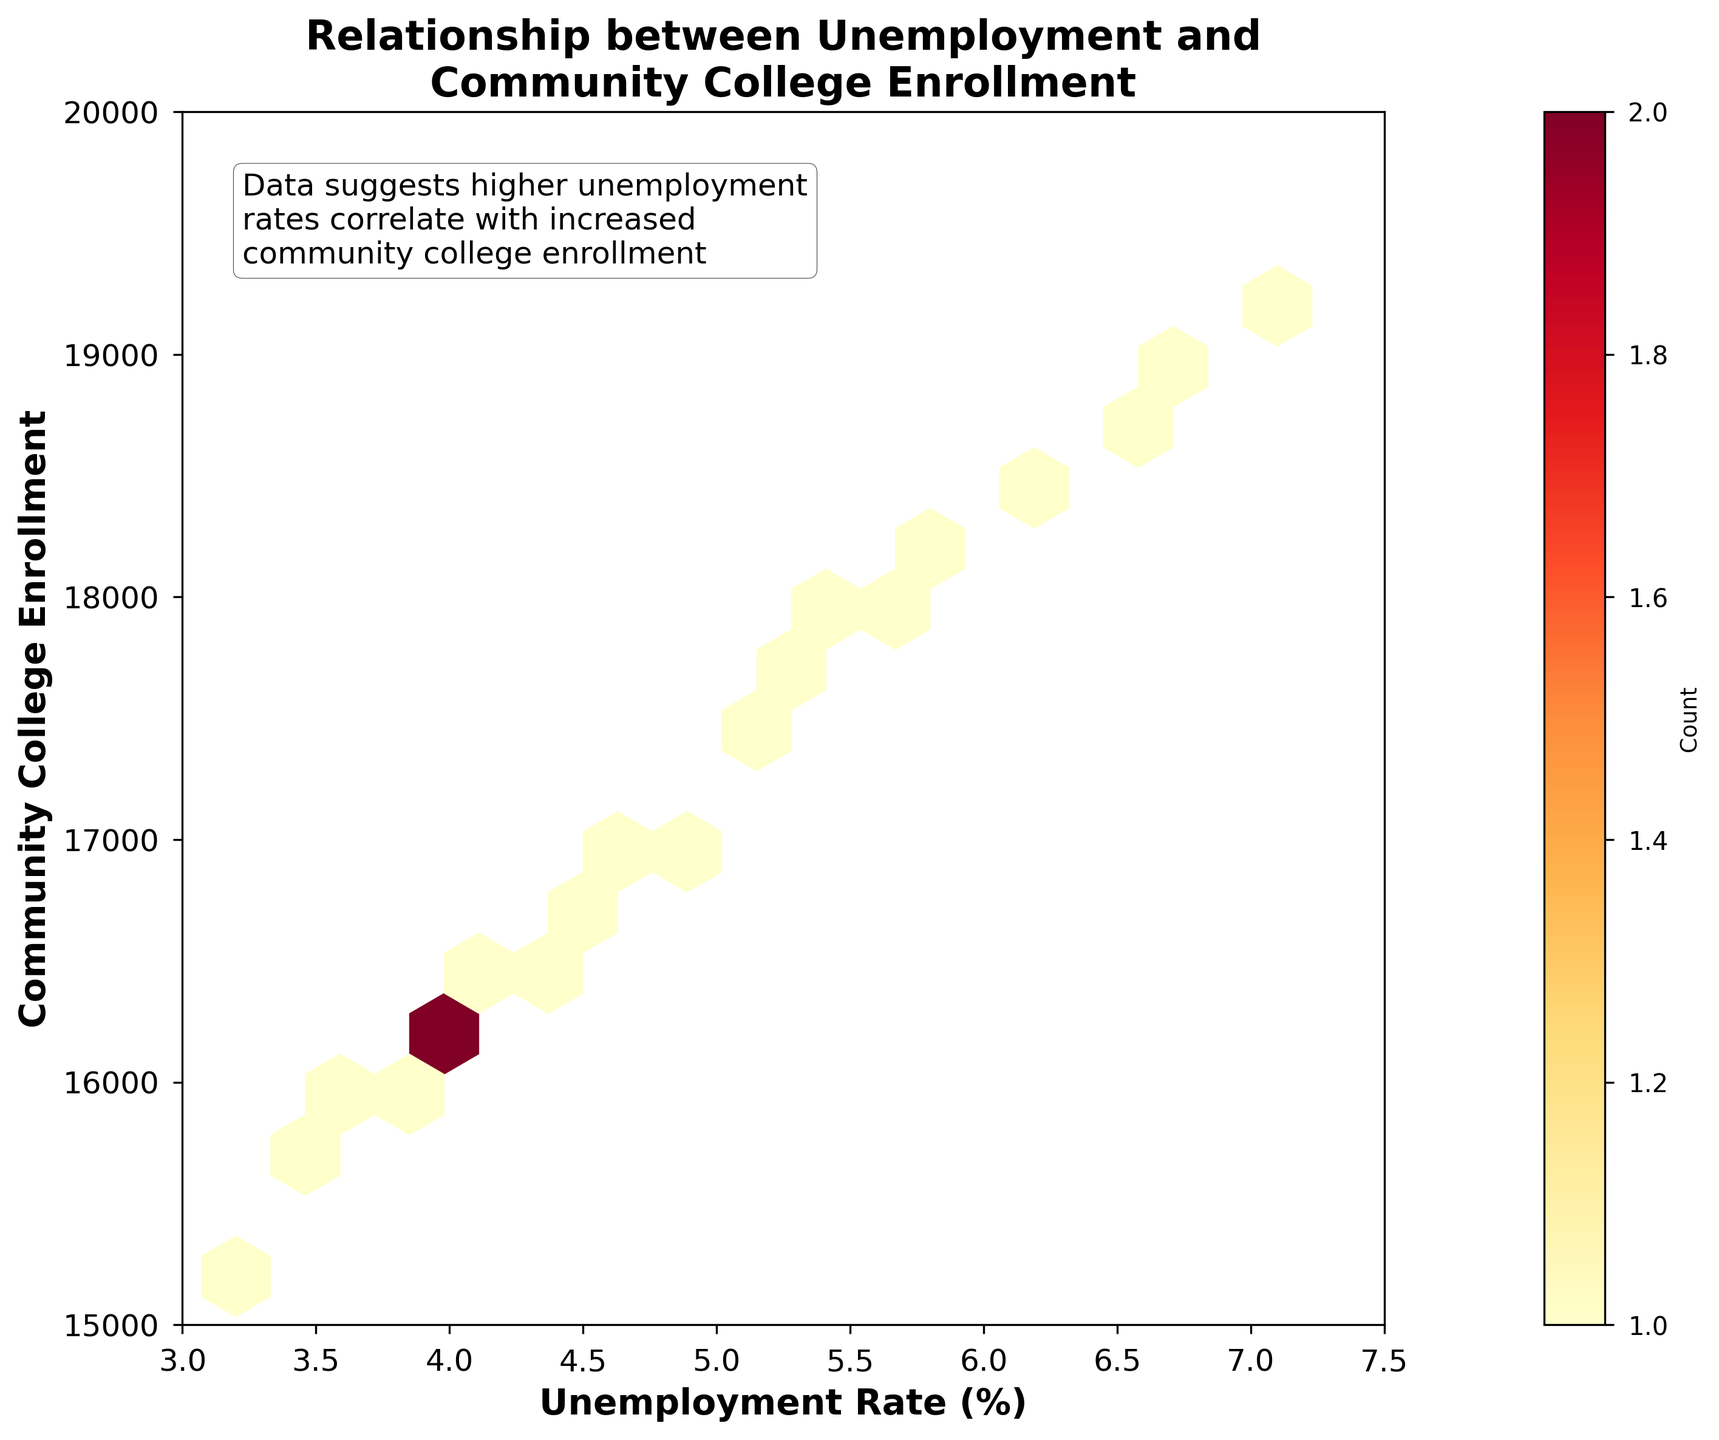What's the title of the figure? The title of the figure is placed at the top of the plot.
Answer: Relationship between Unemployment and Community College Enrollment What color scheme is used in the hexbin plot? Looking at the color variations within the hexagons in the plot, it utilizes a gradient from yellow to red.
Answer: Yellow to red Which axis represents the Unemployment Rate? The x-axis is labeled 'Unemployment Rate (%)', indicating it represents the Unemployment Rate.
Answer: x-axis What is the lowest value on the y-axis? The y-axis starts at 15,000 and extends upwards.
Answer: 15,000 What does a higher density of hexagons indicate about the data points? A higher density of hexagons suggests a higher concentration of data points in that region.
Answer: Higher concentration of data points What is the main message conveyed in the text box within the plot? The text box mentions that the data suggests a correlation between higher unemployment rates and increased community college enrollment.
Answer: Higher unemployment rates correlate with increased community college enrollment How many hexagons are used to bin the data points along each axis? The hexbin plot's 'gridsize' attribute in the code indicates that there are 15 hexagons used to bin data points along each axis.
Answer: 15 When the Unemployment Rate is around 6%, what is the expected range of Community College Enrollment based on the plot? Observing the area where the Unemployment Rate is around 6% on the x-axis, the y-axis shows the Community College Enrollment to be in the range of approximately 18,300 to 18,600.
Answer: 18,300 to 18,600 How does the density of hexagons vary between low and high Unemployment Rates? Observing the density along the x-axis, higher Unemployment Rates appear to have a higher density of hexagons compared to lower rates, indicating more data points.
Answer: Higher Unemployment Rates have a higher density What can you infer if all hexagons were the same color? If all hexagons were the same color, it would indicate that each hexagon contains the same number of data points. In the given plot, this isn't the case, showing variability in data density.
Answer: Equal data point density 